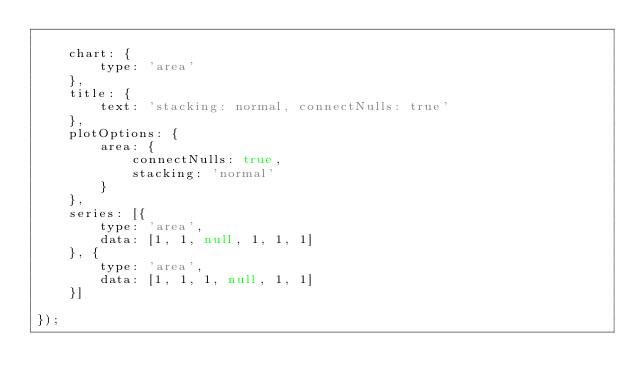<code> <loc_0><loc_0><loc_500><loc_500><_JavaScript_>
    chart: {
        type: 'area'
    },
    title: {
        text: 'stacking: normal, connectNulls: true'
    },
    plotOptions: {
        area: {
            connectNulls: true,
            stacking: 'normal'
        }
    },
    series: [{
        type: 'area',
        data: [1, 1, null, 1, 1, 1]
    }, {
        type: 'area',
        data: [1, 1, 1, null, 1, 1]
    }]

});</code> 